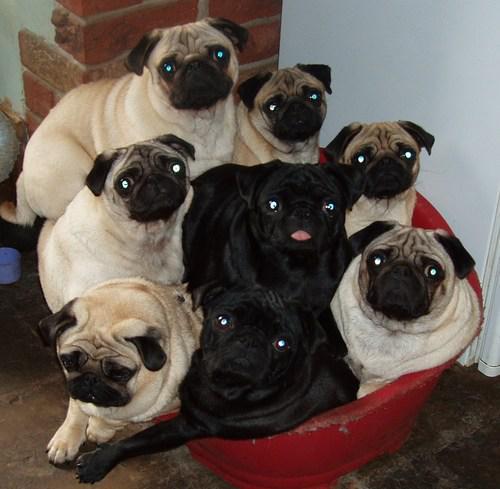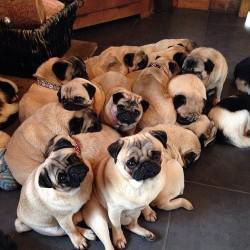The first image is the image on the left, the second image is the image on the right. For the images shown, is this caption "There are less than 5 dogs in the left image." true? Answer yes or no. No. 